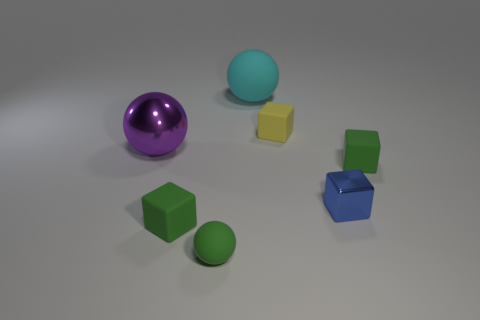Subtract all small shiny cubes. How many cubes are left? 3 Add 2 small rubber blocks. How many objects exist? 9 Subtract all purple balls. How many balls are left? 2 Subtract all cubes. How many objects are left? 3 Subtract all brown cylinders. How many green spheres are left? 1 Subtract 0 brown balls. How many objects are left? 7 Subtract all gray balls. Subtract all cyan cylinders. How many balls are left? 3 Subtract all tiny cyan metal cubes. Subtract all large metallic balls. How many objects are left? 6 Add 4 cyan things. How many cyan things are left? 5 Add 5 tiny yellow things. How many tiny yellow things exist? 6 